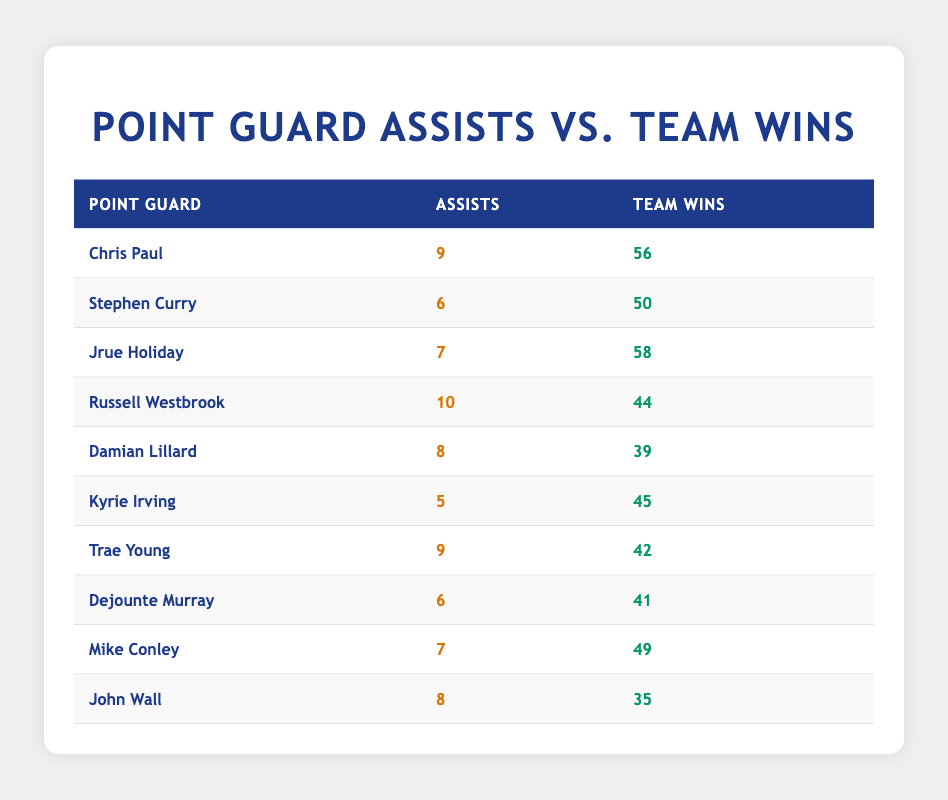What's the highest number of assists recorded by a point guard in the table? Scanning the assists column, I identify the highest value directly. Chris Paul and Russell Westbrook both have 10 assists, which is the highest among all point guards listed.
Answer: 10 Which point guard has the lowest number of team wins? Looking through the team wins column, I find that John Wall has the lowest value at 35 wins.
Answer: 35 What's the total number of assists by all point guards in the table? To find the total, I sum the assists column: (9 + 6 + 7 + 10 + 8 + 5 + 9 + 6 + 7 + 8) = 75.
Answer: 75 Is it true that more assists generally correlate with more team wins? Upon examining the table, I see that Chris Paul has the most assists (9) and also a high number of team wins (56), while Russell Westbrook has the highest assists (10) but fewer wins (44). This indicates a mixed correlation depending on the player and context. Thus, the statement is not always true.
Answer: No What’s the average number of team wins for point guards who have at least 7 assists? First, I filter the table for point guards with 7 or more assists: Chris Paul (56), Jrue Holiday (58), Russell Westbrook (44), Damian Lillard (39), Trae Young (42), and Mike Conley (49). This gives us the wins: (56 + 58 + 44 + 39 + 42 + 49) = 288. There are 6 data points, so the average is 288/6 = 48.
Answer: 48 